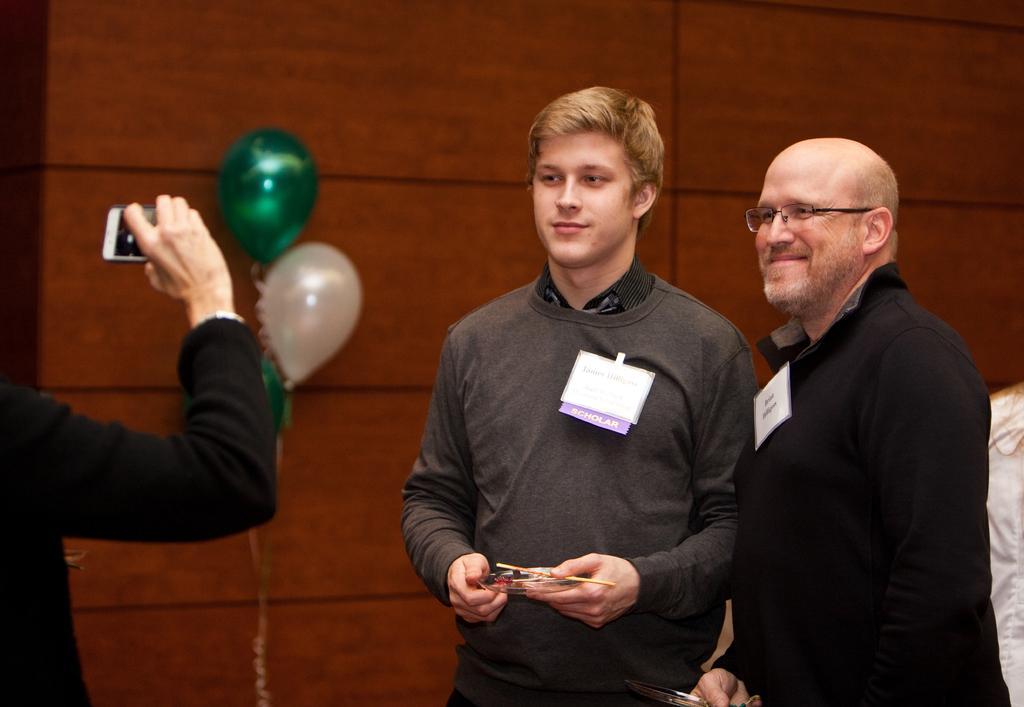In one or two sentences, can you explain what this image depicts? In this image, I can see two persons standing and holding the objects. On the left side of the image, I can see another person holding a mobile. In the background there are balloons and a wall. 